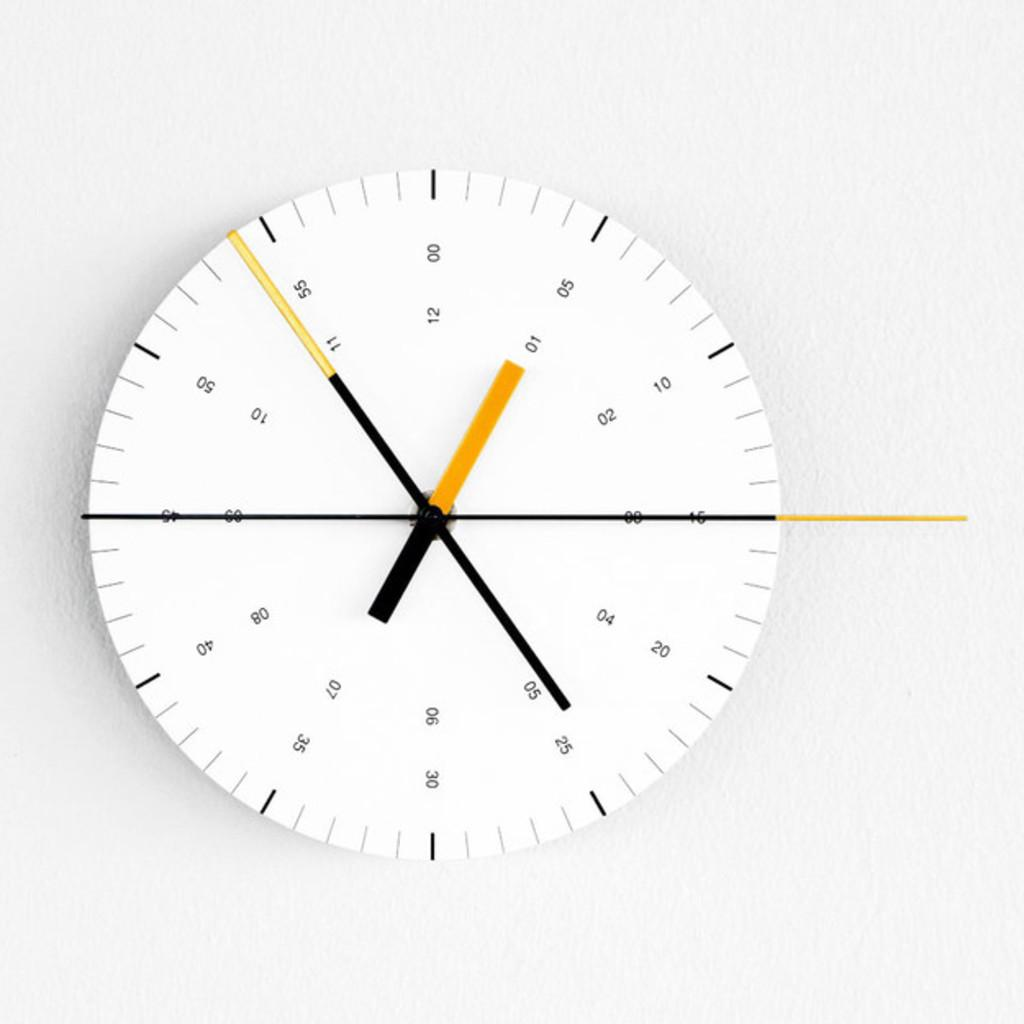Provide a one-sentence caption for the provided image. The small yellow hand on the clock points to 01 05. 